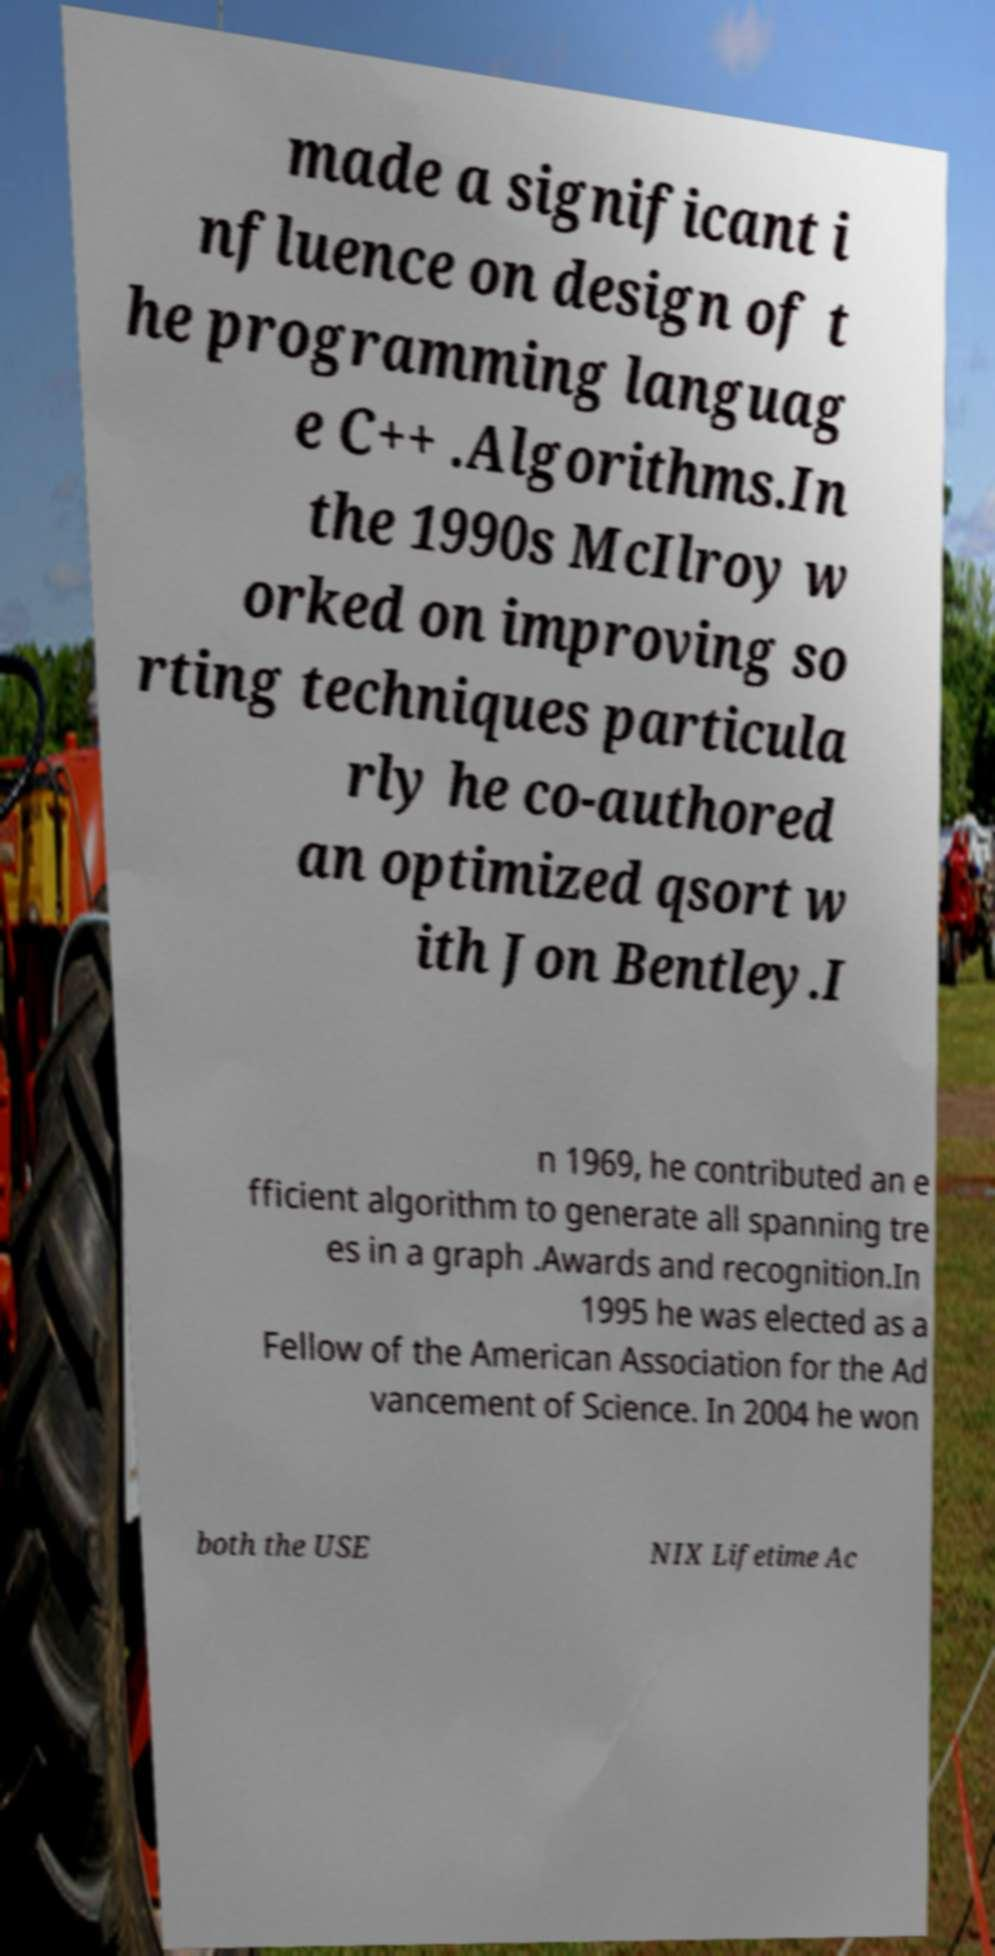Could you extract and type out the text from this image? made a significant i nfluence on design of t he programming languag e C++ .Algorithms.In the 1990s McIlroy w orked on improving so rting techniques particula rly he co-authored an optimized qsort w ith Jon Bentley.I n 1969, he contributed an e fficient algorithm to generate all spanning tre es in a graph .Awards and recognition.In 1995 he was elected as a Fellow of the American Association for the Ad vancement of Science. In 2004 he won both the USE NIX Lifetime Ac 